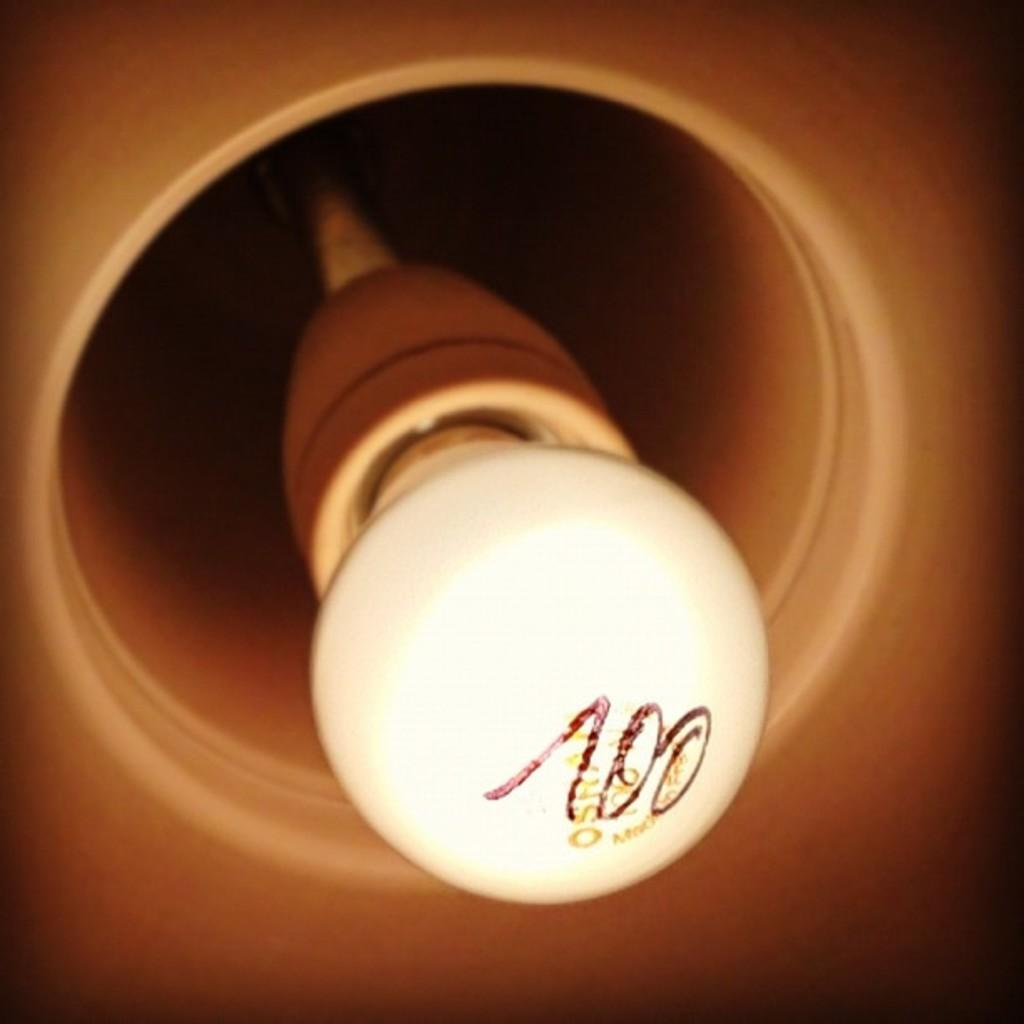What is the main subject of the image? The main subject of the image is a blown bulb. What type of grape is hanging from the crib in the image? There is no grape or crib present in the image; it only features a blown bulb. 